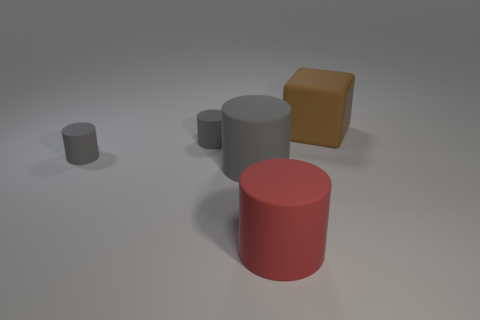How many gray cylinders must be subtracted to get 2 gray cylinders? 1 Subtract all cyan cubes. How many gray cylinders are left? 3 Subtract 1 cylinders. How many cylinders are left? 3 Add 3 brown rubber cubes. How many objects exist? 8 Subtract all blocks. How many objects are left? 4 Add 3 big red matte cylinders. How many big red matte cylinders are left? 4 Add 1 large green metal things. How many large green metal things exist? 1 Subtract 1 gray cylinders. How many objects are left? 4 Subtract all gray cylinders. Subtract all big brown matte cubes. How many objects are left? 1 